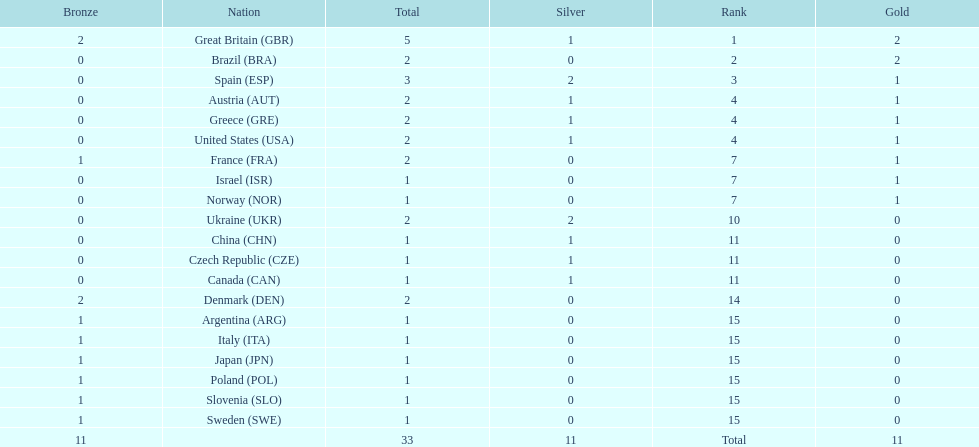Which nation was the only one to receive 3 medals? Spain (ESP). 